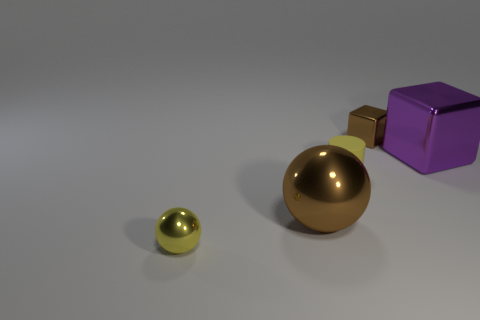There is another object that is the same size as the purple object; what is its shape?
Provide a short and direct response. Sphere. How many tiny yellow rubber cylinders are in front of the yellow object that is on the right side of the ball to the left of the brown metallic sphere?
Offer a terse response. 0. How many rubber objects are either big brown things or small brown objects?
Give a very brief answer. 0. The shiny thing that is both right of the small cylinder and to the left of the large purple shiny thing is what color?
Your answer should be very brief. Brown. Is the size of the yellow sphere that is in front of the brown metallic cube the same as the small yellow rubber object?
Offer a very short reply. Yes. How many things are either big metallic objects that are left of the small brown cube or large metal balls?
Offer a terse response. 1. Is there a brown ball of the same size as the cylinder?
Provide a short and direct response. No. What is the material of the sphere that is the same size as the purple shiny block?
Your answer should be compact. Metal. What is the shape of the object that is behind the yellow shiny thing and in front of the matte thing?
Offer a terse response. Sphere. The large object right of the tiny rubber object is what color?
Ensure brevity in your answer.  Purple. 